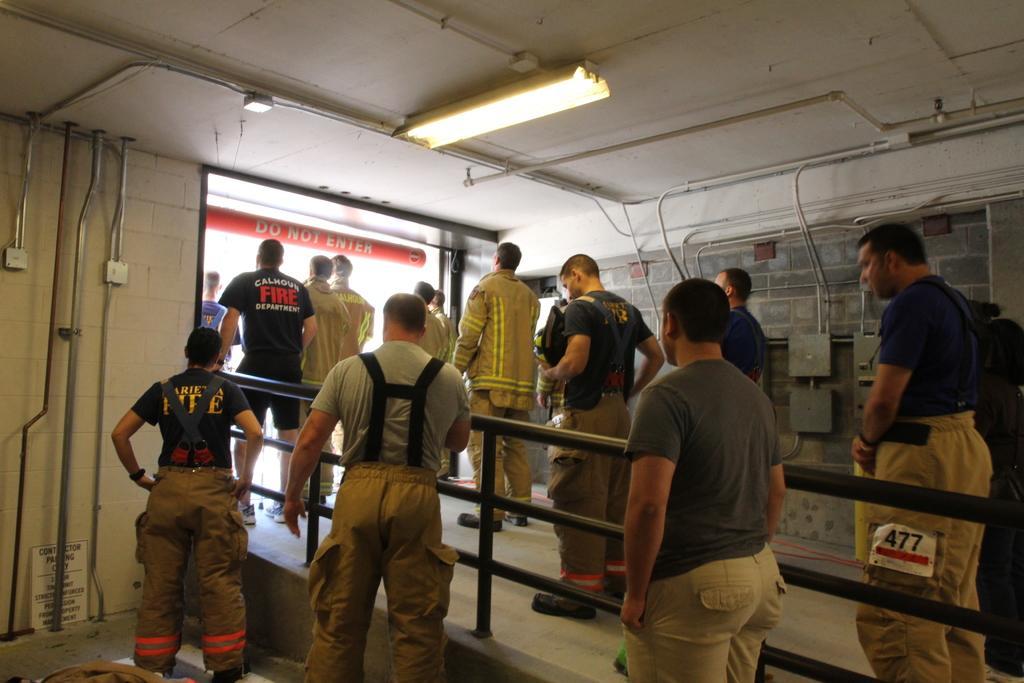In one or two sentences, can you explain what this image depicts? In the left side 3 men are standing, in the right side few other men also standing, at the top there is a light. 